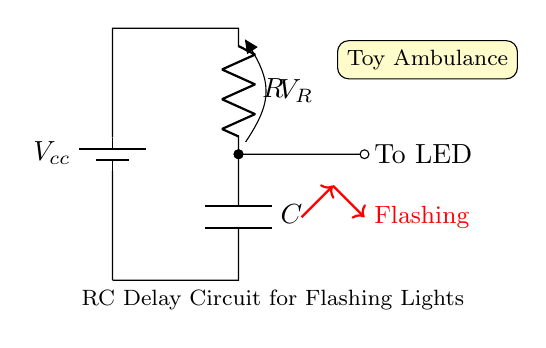What is the component labeled R in the circuit? The component labeled R is a resistor, which is defined in the circuit diagram. It is typically represented by the symbol R and serves to limit the current flow in the circuit.
Answer: Resistor What is the role of the component labeled C in the circuit? The component labeled C is a capacitor, which stores electrical energy. In this RC circuit, it helps create a delay by charging and discharging, influencing how the flashing lights operate.
Answer: Capacitor What device is connected to the output of the resistor? The device connected to the output of the resistor is an LED, which lights up when current flows through it. In the diagram, it is shown as connected to the wire leading from R to indicate where the flashing action occurs.
Answer: LED How does the RC circuit affect the flashing lights? The RC circuit affects the flashing lights by creating a timing delay. As the capacitor charges through the resistor, the voltage across it increases, which affects when the LED turns on and off, creating the flashing effect.
Answer: Creates timing delay What does Vcc represent in the circuit? Vcc represents the supply voltage for the circuit, which is the potential difference providing power to the circuit components, ensuring that they function correctly.
Answer: Supply voltage What would happen if the resistance value R is increased? If the resistance value R is increased, the charging time of the capacitor C would become longer, resulting in a slower flashing rate for the LED as it takes more time to reach the voltage necessary to turn on the LED.
Answer: Slower flashing rate 